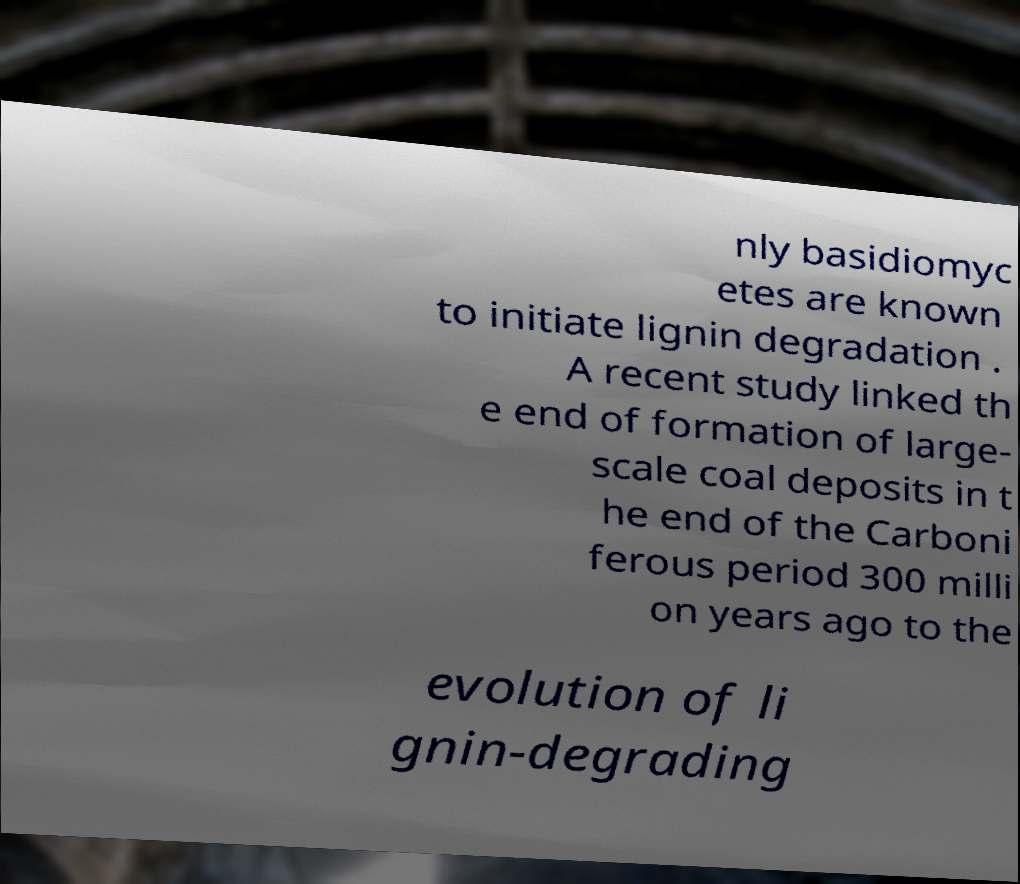Can you accurately transcribe the text from the provided image for me? nly basidiomyc etes are known to initiate lignin degradation . A recent study linked th e end of formation of large- scale coal deposits in t he end of the Carboni ferous period 300 milli on years ago to the evolution of li gnin-degrading 